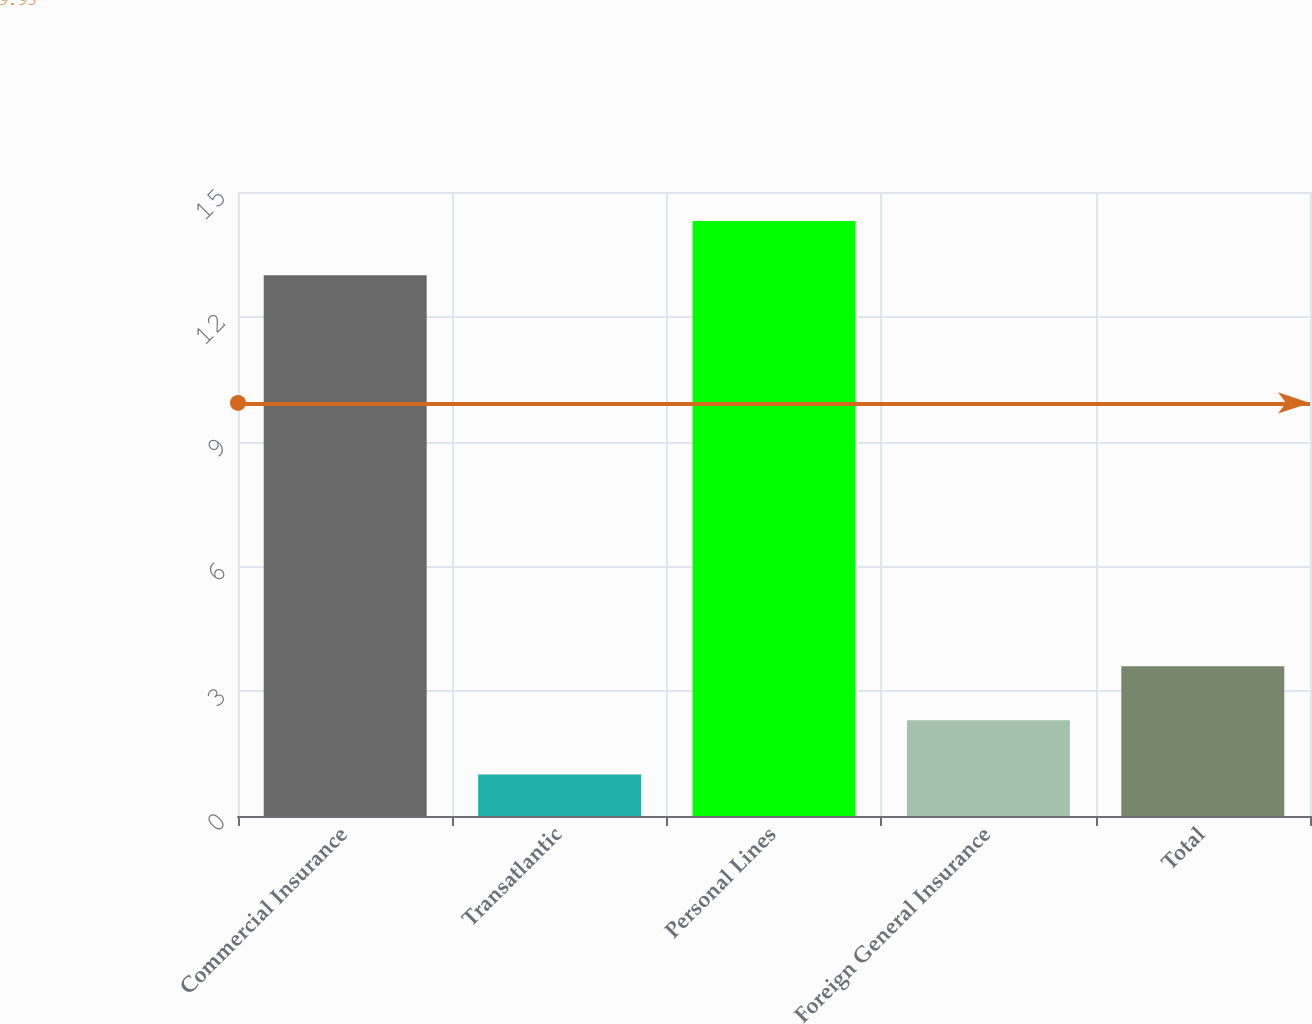<chart> <loc_0><loc_0><loc_500><loc_500><bar_chart><fcel>Commercial Insurance<fcel>Transatlantic<fcel>Personal Lines<fcel>Foreign General Insurance<fcel>Total<nl><fcel>13<fcel>1<fcel>14.3<fcel>2.3<fcel>3.6<nl></chart> 